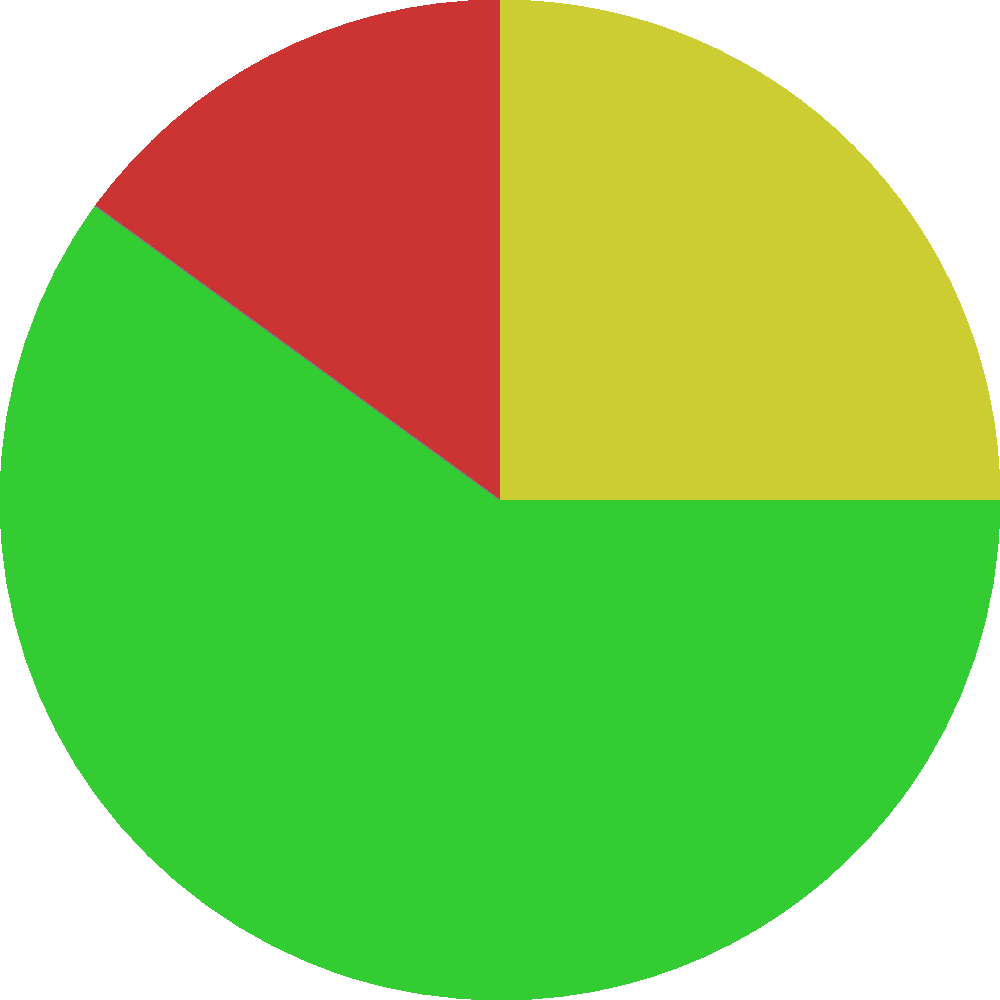In the pie chart representing customer feedback sentiment, what percentage of feedback is categorized as positive, and how does this compare to the combined percentage of negative and mixed feedback? To answer this question, we need to analyze the pie chart and perform some calculations:

1. Identify the percentage of positive feedback:
   The pie chart shows that 40% of the feedback is positive.

2. Identify the percentages of negative and mixed feedback:
   Negative feedback: 20%
   Mixed feedback: 10%

3. Calculate the combined percentage of negative and mixed feedback:
   $20\% + 10\% = 30\%$

4. Compare positive feedback to the combined negative and mixed feedback:
   Positive feedback: 40%
   Combined negative and mixed: 30%

5. Calculate the difference:
   $40\% - 30\% = 10\%$

Therefore, the percentage of positive feedback (40%) is 10 percentage points higher than the combined percentage of negative and mixed feedback (30%).
Answer: 40%; 10 percentage points higher 